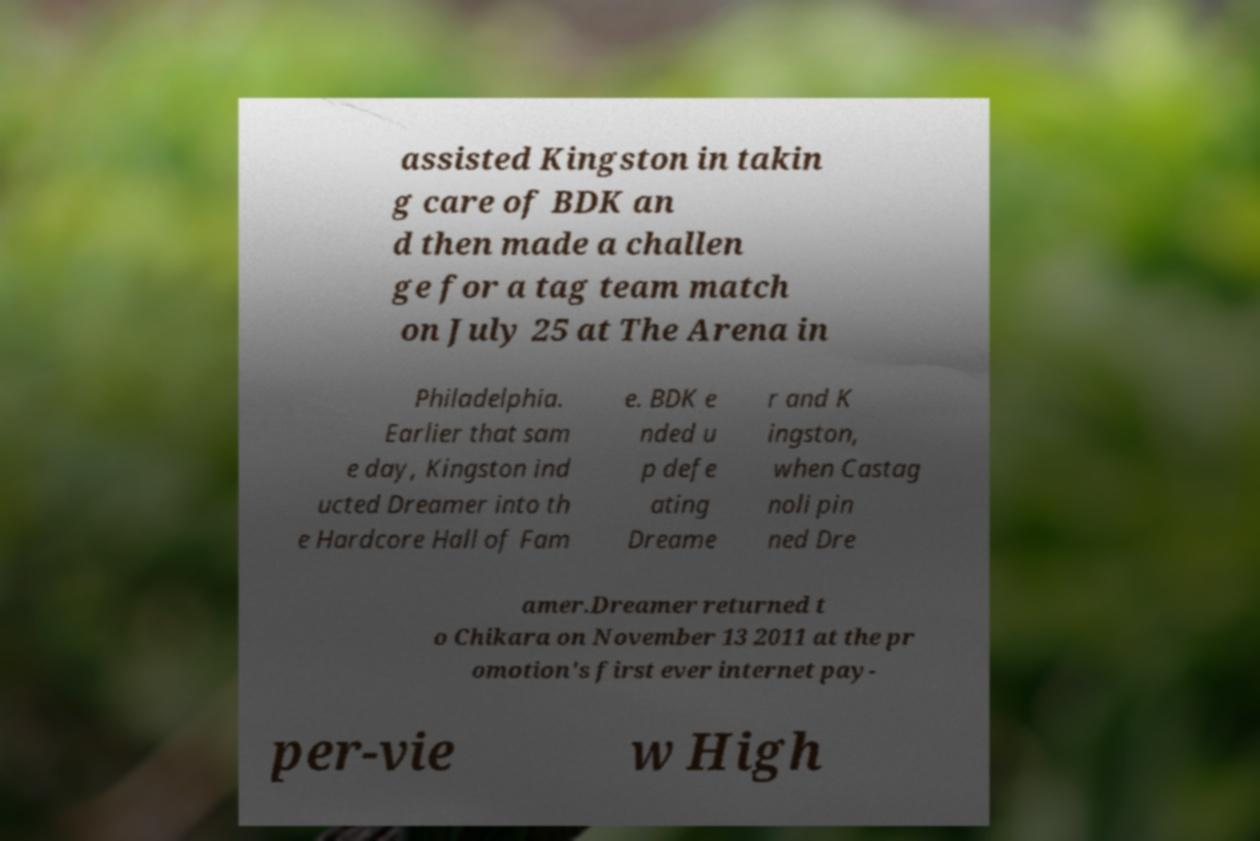Please identify and transcribe the text found in this image. assisted Kingston in takin g care of BDK an d then made a challen ge for a tag team match on July 25 at The Arena in Philadelphia. Earlier that sam e day, Kingston ind ucted Dreamer into th e Hardcore Hall of Fam e. BDK e nded u p defe ating Dreame r and K ingston, when Castag noli pin ned Dre amer.Dreamer returned t o Chikara on November 13 2011 at the pr omotion's first ever internet pay- per-vie w High 